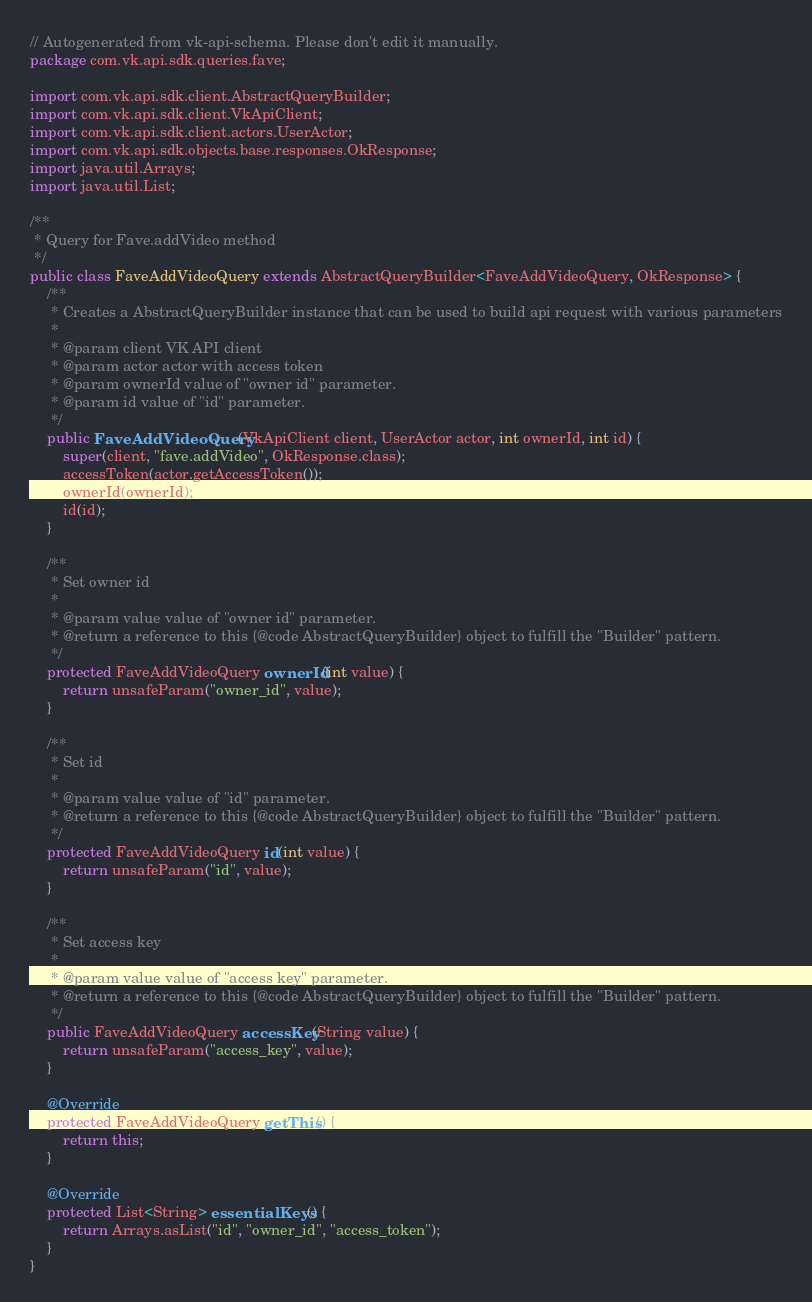<code> <loc_0><loc_0><loc_500><loc_500><_Java_>// Autogenerated from vk-api-schema. Please don't edit it manually.
package com.vk.api.sdk.queries.fave;

import com.vk.api.sdk.client.AbstractQueryBuilder;
import com.vk.api.sdk.client.VkApiClient;
import com.vk.api.sdk.client.actors.UserActor;
import com.vk.api.sdk.objects.base.responses.OkResponse;
import java.util.Arrays;
import java.util.List;

/**
 * Query for Fave.addVideo method
 */
public class FaveAddVideoQuery extends AbstractQueryBuilder<FaveAddVideoQuery, OkResponse> {
    /**
     * Creates a AbstractQueryBuilder instance that can be used to build api request with various parameters
     *
     * @param client VK API client
     * @param actor actor with access token
     * @param ownerId value of "owner id" parameter.
     * @param id value of "id" parameter.
     */
    public FaveAddVideoQuery(VkApiClient client, UserActor actor, int ownerId, int id) {
        super(client, "fave.addVideo", OkResponse.class);
        accessToken(actor.getAccessToken());
        ownerId(ownerId);
        id(id);
    }

    /**
     * Set owner id
     *
     * @param value value of "owner id" parameter.
     * @return a reference to this {@code AbstractQueryBuilder} object to fulfill the "Builder" pattern.
     */
    protected FaveAddVideoQuery ownerId(int value) {
        return unsafeParam("owner_id", value);
    }

    /**
     * Set id
     *
     * @param value value of "id" parameter.
     * @return a reference to this {@code AbstractQueryBuilder} object to fulfill the "Builder" pattern.
     */
    protected FaveAddVideoQuery id(int value) {
        return unsafeParam("id", value);
    }

    /**
     * Set access key
     *
     * @param value value of "access key" parameter.
     * @return a reference to this {@code AbstractQueryBuilder} object to fulfill the "Builder" pattern.
     */
    public FaveAddVideoQuery accessKey(String value) {
        return unsafeParam("access_key", value);
    }

    @Override
    protected FaveAddVideoQuery getThis() {
        return this;
    }

    @Override
    protected List<String> essentialKeys() {
        return Arrays.asList("id", "owner_id", "access_token");
    }
}
</code> 